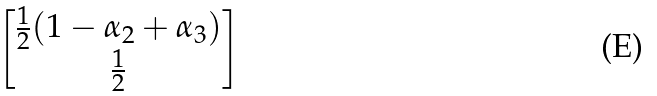Convert formula to latex. <formula><loc_0><loc_0><loc_500><loc_500>\begin{bmatrix} \frac { 1 } { 2 } ( 1 - \alpha _ { 2 } + \alpha _ { 3 } ) \\ \frac { 1 } { 2 } \end{bmatrix}</formula> 